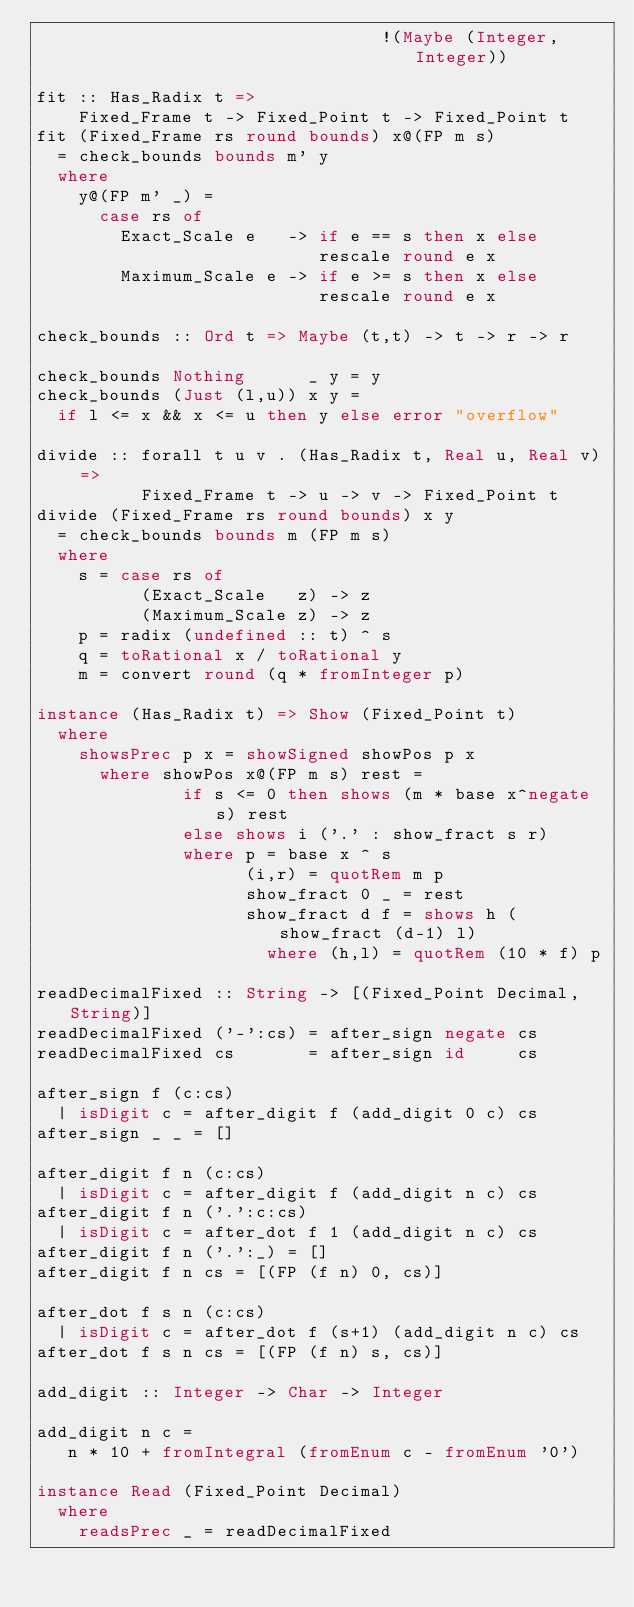<code> <loc_0><loc_0><loc_500><loc_500><_Haskell_>                                 !(Maybe (Integer, Integer))

fit :: Has_Radix t =>
    Fixed_Frame t -> Fixed_Point t -> Fixed_Point t
fit (Fixed_Frame rs round bounds) x@(FP m s)
  = check_bounds bounds m' y
  where
    y@(FP m' _) =
      case rs of
        Exact_Scale e   -> if e == s then x else
                           rescale round e x
        Maximum_Scale e -> if e >= s then x else
                           rescale round e x

check_bounds :: Ord t => Maybe (t,t) -> t -> r -> r

check_bounds Nothing      _ y = y
check_bounds (Just (l,u)) x y =
  if l <= x && x <= u then y else error "overflow"

divide :: forall t u v . (Has_Radix t, Real u, Real v) =>
          Fixed_Frame t -> u -> v -> Fixed_Point t
divide (Fixed_Frame rs round bounds) x y
  = check_bounds bounds m (FP m s)
  where
    s = case rs of
          (Exact_Scale   z) -> z
          (Maximum_Scale z) -> z
    p = radix (undefined :: t) ^ s
    q = toRational x / toRational y
    m = convert round (q * fromInteger p)

instance (Has_Radix t) => Show (Fixed_Point t)
  where
    showsPrec p x = showSigned showPos p x
      where showPos x@(FP m s) rest =
              if s <= 0 then shows (m * base x^negate s) rest
              else shows i ('.' : show_fract s r)
              where p = base x ^ s
                    (i,r) = quotRem m p
                    show_fract 0 _ = rest
                    show_fract d f = shows h (show_fract (d-1) l)
                      where (h,l) = quotRem (10 * f) p

readDecimalFixed :: String -> [(Fixed_Point Decimal,String)]
readDecimalFixed ('-':cs) = after_sign negate cs
readDecimalFixed cs       = after_sign id     cs

after_sign f (c:cs)
  | isDigit c = after_digit f (add_digit 0 c) cs
after_sign _ _ = []

after_digit f n (c:cs)
  | isDigit c = after_digit f (add_digit n c) cs
after_digit f n ('.':c:cs)
  | isDigit c = after_dot f 1 (add_digit n c) cs
after_digit f n ('.':_) = []
after_digit f n cs = [(FP (f n) 0, cs)]

after_dot f s n (c:cs)
  | isDigit c = after_dot f (s+1) (add_digit n c) cs
after_dot f s n cs = [(FP (f n) s, cs)]

add_digit :: Integer -> Char -> Integer

add_digit n c =
   n * 10 + fromIntegral (fromEnum c - fromEnum '0')

instance Read (Fixed_Point Decimal)
  where
    readsPrec _ = readDecimalFixed

</code> 